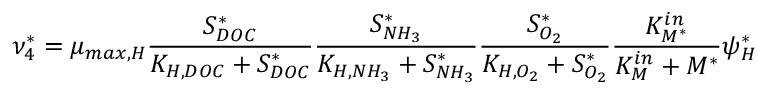Convert formula to latex. <formula><loc_0><loc_0><loc_500><loc_500>\nu _ { 4 } ^ { * } = \mu _ { \max , H } \frac { S _ { D O C } ^ { * } } { K _ { H , D O C } + S _ { D O C } ^ { * } } \frac { S _ { N H _ { 3 } } ^ { * } } { K _ { H , N H _ { 3 } } + S _ { N H _ { 3 } } ^ { * } } \frac { S _ { O _ { 2 } } ^ { * } } { K _ { H , O _ { 2 } } + S _ { O _ { 2 } } ^ { * } } \frac { K _ { M ^ { * } } ^ { i n } } { K _ { M } ^ { i n } + M ^ { * } } \psi _ { H } ^ { * }</formula> 